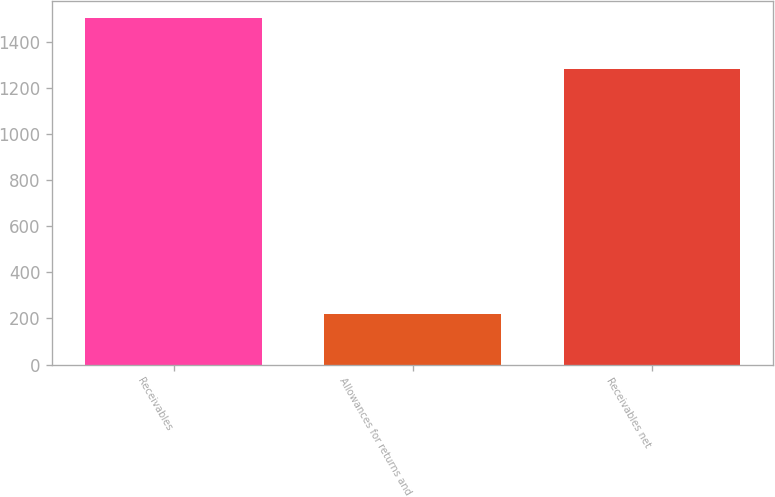<chart> <loc_0><loc_0><loc_500><loc_500><bar_chart><fcel>Receivables<fcel>Allowances for returns and<fcel>Receivables net<nl><fcel>1503<fcel>220<fcel>1283<nl></chart> 